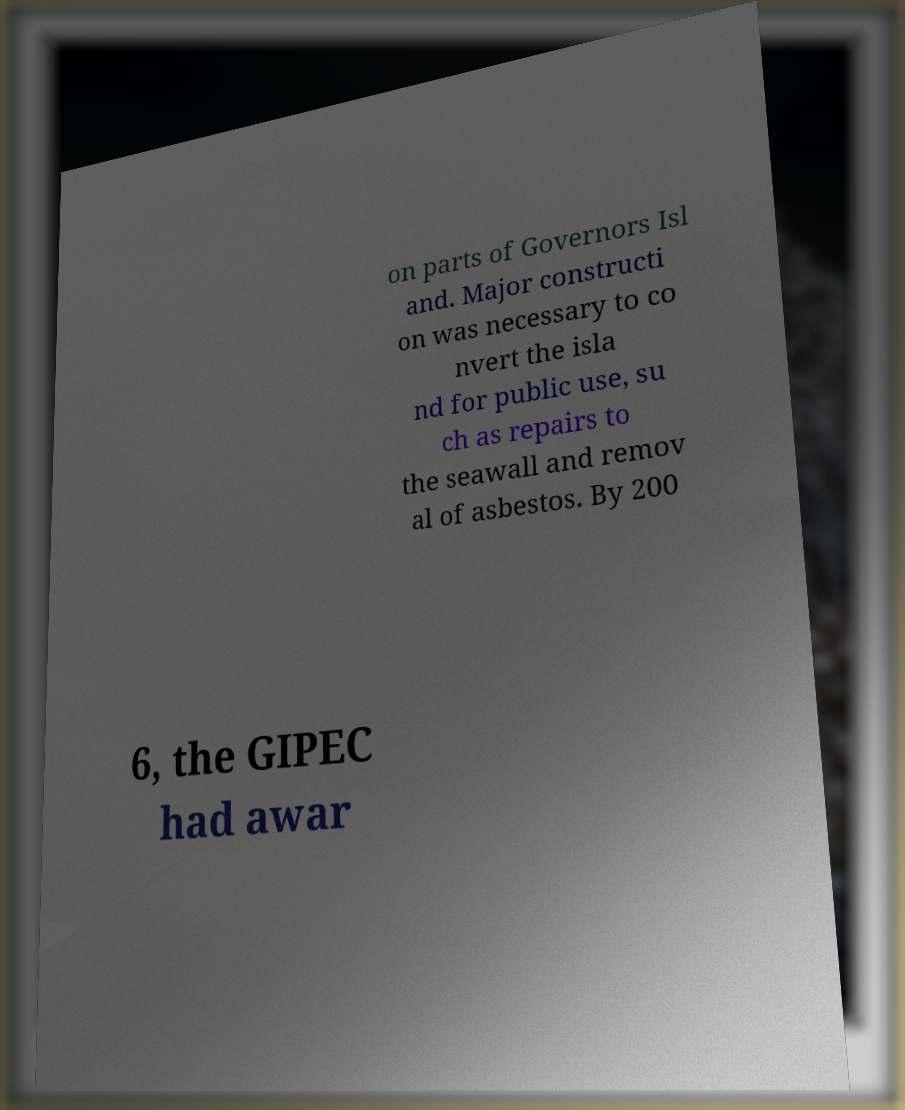Could you extract and type out the text from this image? on parts of Governors Isl and. Major constructi on was necessary to co nvert the isla nd for public use, su ch as repairs to the seawall and remov al of asbestos. By 200 6, the GIPEC had awar 